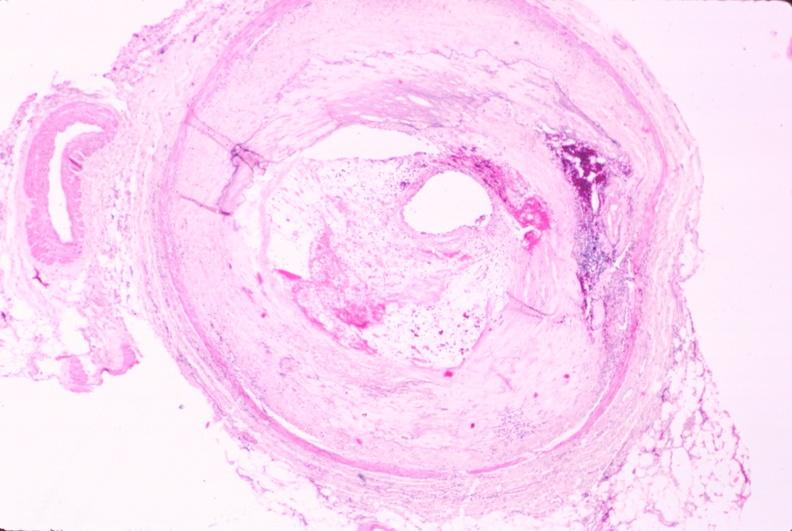what is present?
Answer the question using a single word or phrase. Cardiovascular 